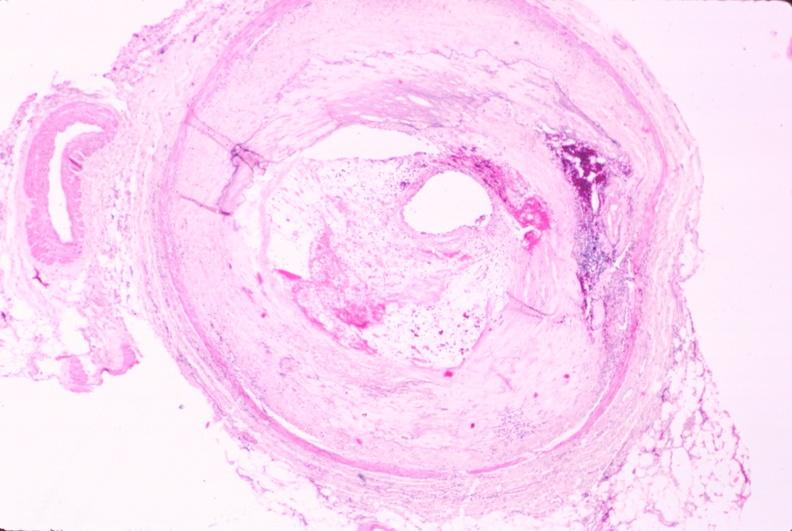what is present?
Answer the question using a single word or phrase. Cardiovascular 